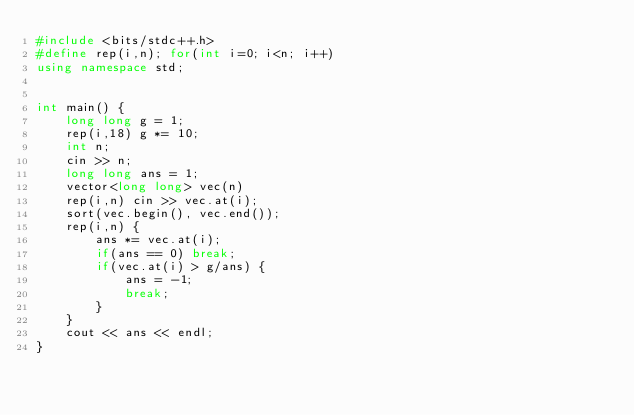<code> <loc_0><loc_0><loc_500><loc_500><_C++_>#include <bits/stdc++.h>
#define rep(i,n); for(int i=0; i<n; i++)
using namespace std;


int main() {
    long long g = 1;
    rep(i,18) g *= 10;
    int n;
    cin >> n;
    long long ans = 1;
    vector<long long> vec(n)
    rep(i,n) cin >> vec.at(i);
    sort(vec.begin(), vec.end());
    rep(i,n) {
        ans *= vec.at(i);
        if(ans == 0) break;
        if(vec.at(i) > g/ans) {
            ans = -1;
            break;
        }
    }
    cout << ans << endl;
}

</code> 